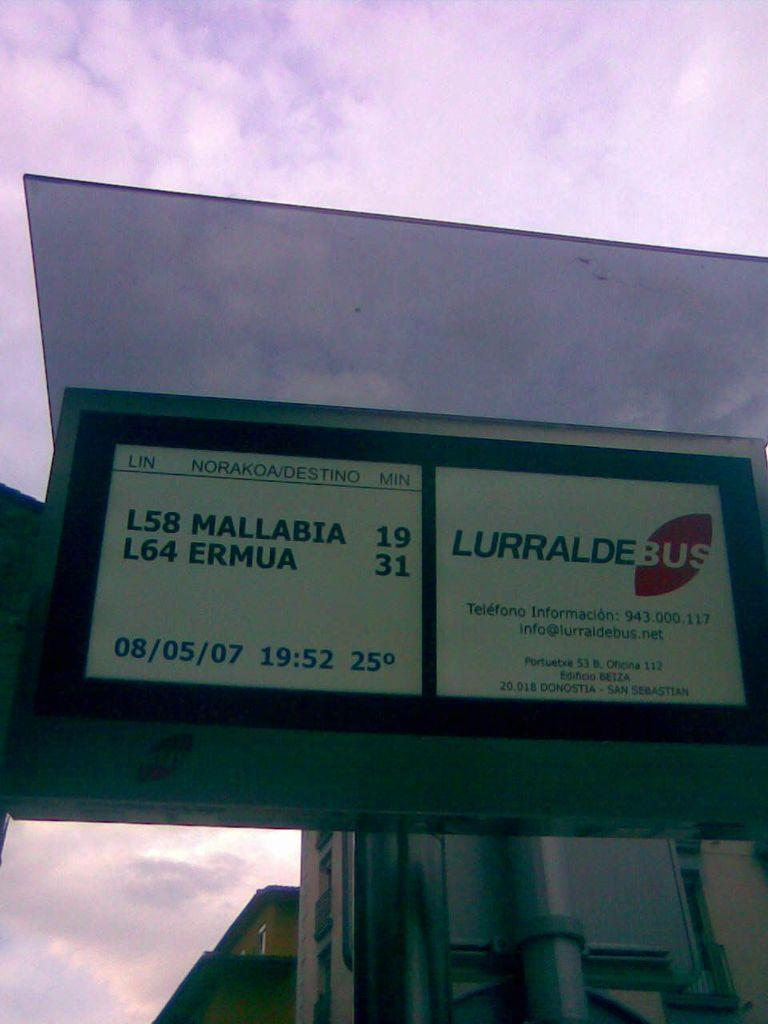<image>
Present a compact description of the photo's key features. The marquee states on the left side bottom 08/05/07 19:52 25 degrees. 